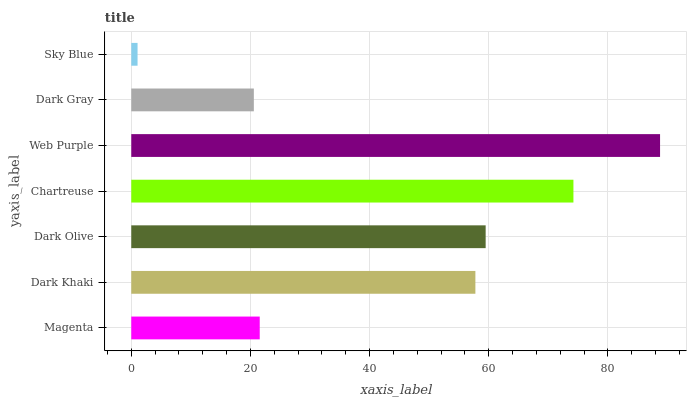Is Sky Blue the minimum?
Answer yes or no. Yes. Is Web Purple the maximum?
Answer yes or no. Yes. Is Dark Khaki the minimum?
Answer yes or no. No. Is Dark Khaki the maximum?
Answer yes or no. No. Is Dark Khaki greater than Magenta?
Answer yes or no. Yes. Is Magenta less than Dark Khaki?
Answer yes or no. Yes. Is Magenta greater than Dark Khaki?
Answer yes or no. No. Is Dark Khaki less than Magenta?
Answer yes or no. No. Is Dark Khaki the high median?
Answer yes or no. Yes. Is Dark Khaki the low median?
Answer yes or no. Yes. Is Sky Blue the high median?
Answer yes or no. No. Is Magenta the low median?
Answer yes or no. No. 